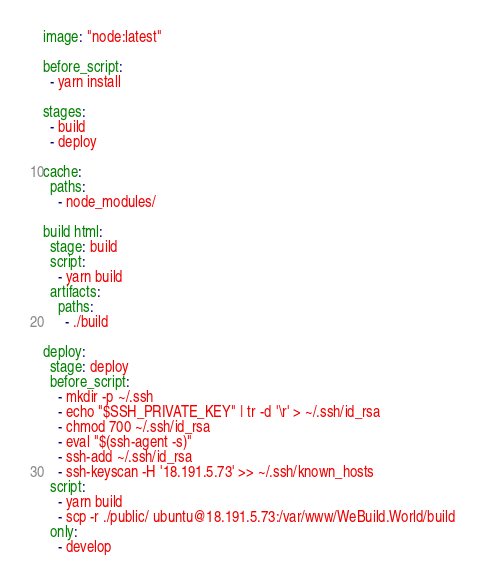Convert code to text. <code><loc_0><loc_0><loc_500><loc_500><_YAML_>image: "node:latest"

before_script:
  - yarn install

stages:
  - build
  - deploy

cache:
  paths:
    - node_modules/

build html:
  stage: build
  script:
    - yarn build
  artifacts:
    paths:
      - ./build

deploy:
  stage: deploy
  before_script:
    - mkdir -p ~/.ssh
    - echo "$SSH_PRIVATE_KEY" | tr -d '\r' > ~/.ssh/id_rsa
    - chmod 700 ~/.ssh/id_rsa
    - eval "$(ssh-agent -s)"
    - ssh-add ~/.ssh/id_rsa
    - ssh-keyscan -H '18.191.5.73' >> ~/.ssh/known_hosts
  script:
    - yarn build
    - scp -r ./public/ ubuntu@18.191.5.73:/var/www/WeBuild.World/build
  only:
    - develop

</code> 